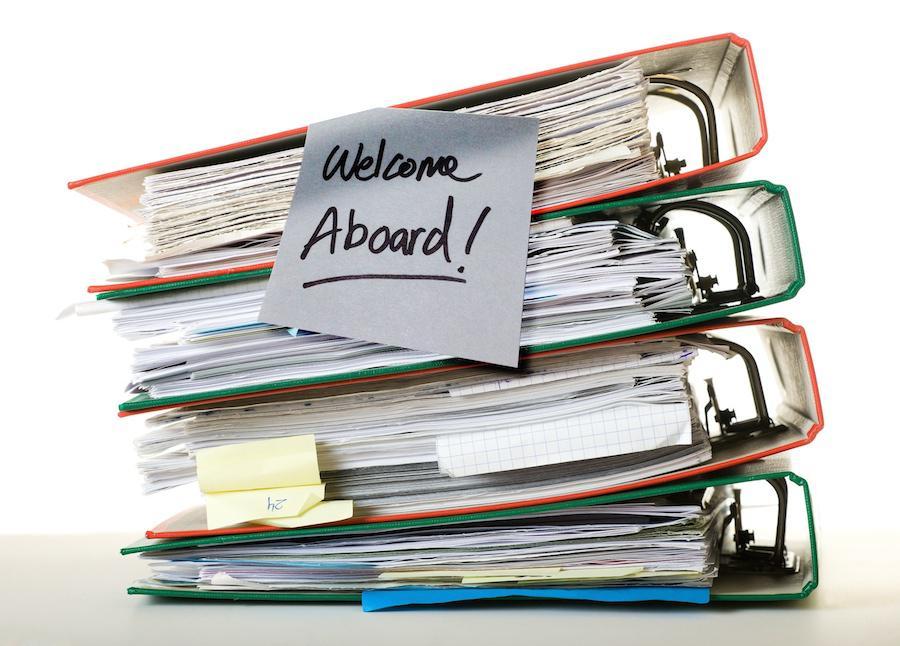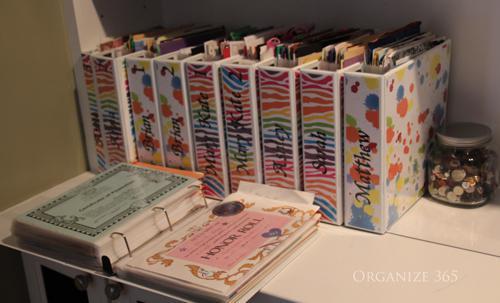The first image is the image on the left, the second image is the image on the right. Assess this claim about the two images: "There is one open binder in the right image.". Correct or not? Answer yes or no. Yes. 